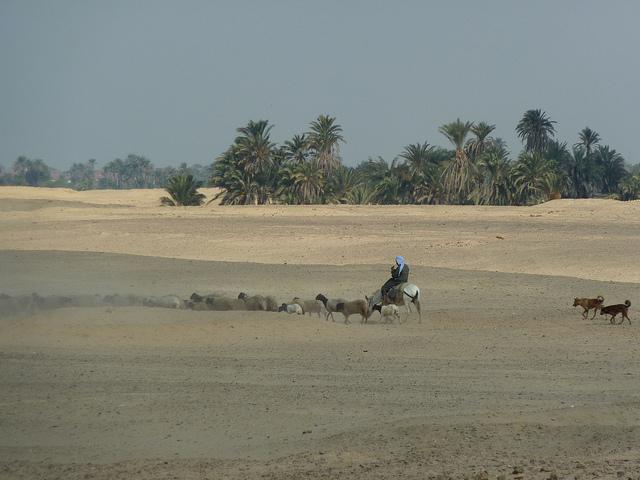Where is the man riding through? Please explain your reasoning. desert. The man is by the desert. 